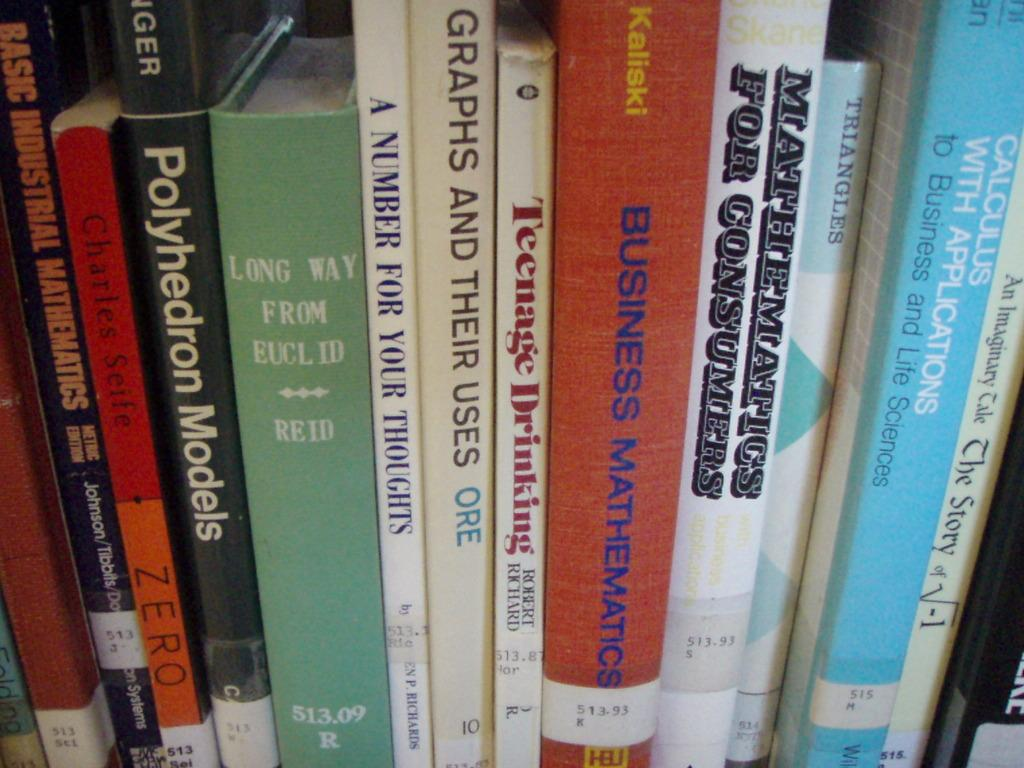<image>
Provide a brief description of the given image. A shelf of books, one of them titled A Number For Your Thoughts. 